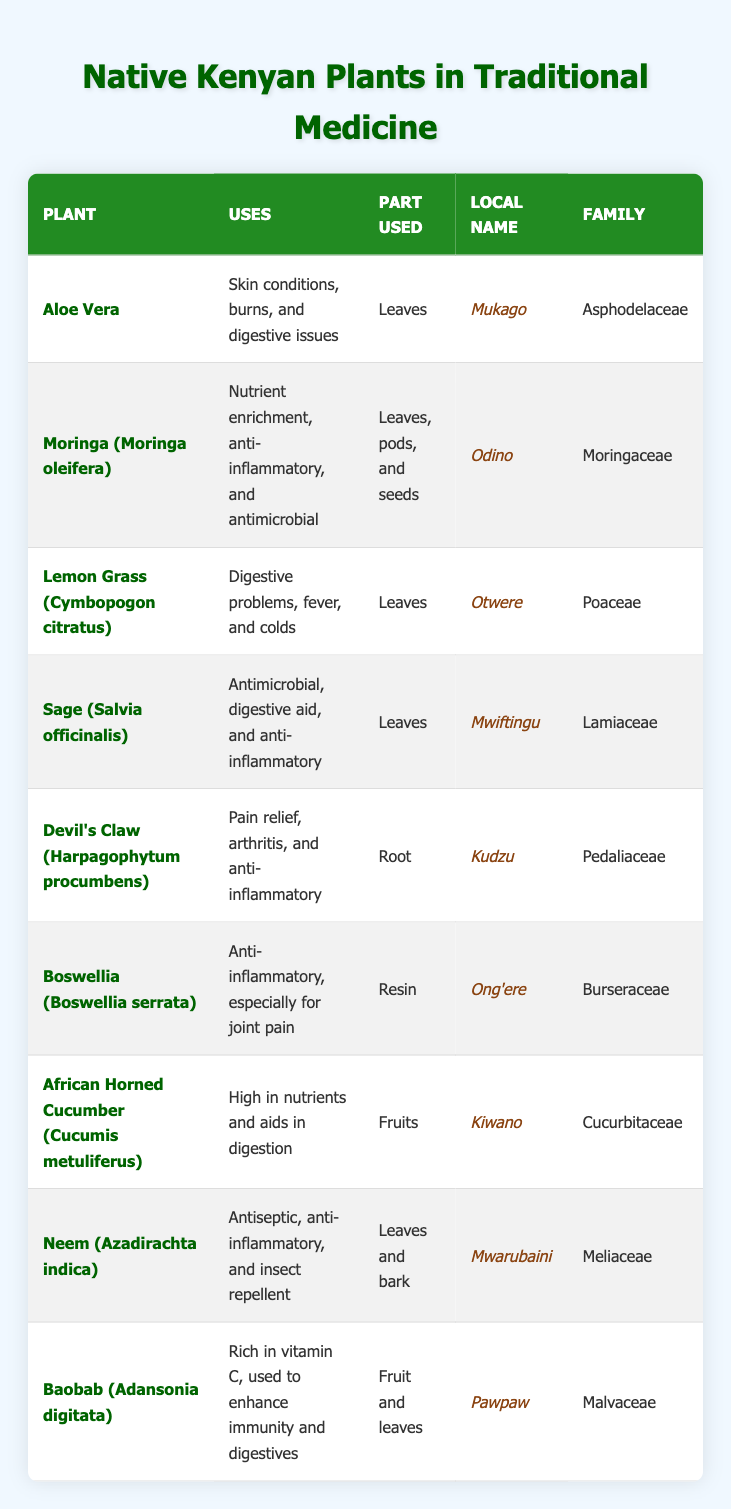What is the local name of Aloe Vera? In the table, under the "Local Name" column for the plant "Aloe Vera," it is listed as "Mukago."
Answer: Mukago Which part of the Moringa plant is used? The table specifies that for Moringa (Moringa oleifera), the parts used are "Leaves, pods, and seeds."
Answer: Leaves, pods, and seeds Is Neem used for antiseptic purposes? The table lists Neem (Azadirachta indica) under "Uses," mentioning antiseptic properties. Therefore, the answer is yes.
Answer: Yes How many plants listed are primarily used for digestive issues? The table mentions "Aloe Vera," "Lemon Grass," and "Baobab" as used for digestive issues. Counting these gives us three plants.
Answer: 3 Which plant has the highest diversity in parts used? Moringa (Moringa oleifera) is the only plant that lists "Leaves, pods, and seeds," showing varied usage. Therefore, it has the highest diversity with three parts.
Answer: Moringa What are the uses of the Baobab plant? The "Uses" column for Baobab (Adansonia digitata) indicates it is "Rich in vitamin C, used to enhance immunity and digestives."
Answer: Rich in vitamin C Which plants are in the Lamiaceae family? By reviewing the "Family" column, we can see that Sage (Salvia officinalis) is the only plant in the Lamiaceae family.
Answer: Sage List the parts used for Devil’s Claw. The table shows that the part used for Devil's Claw (Harpagophytum procumbens) is the "Root."
Answer: Root Are there any plants that are used as insect repellents? Neem (Azadirachta indica) is listed in the "Uses" column as having insect repellent properties, so the answer is yes.
Answer: Yes Among the listed plants, which part of the Boswellia tree is used? The "Part Used" column indicates that Boswellia (Boswellia serrata) uses "Resin."
Answer: Resin How many plants use leaves as part of their medicinal application? By counting the plants in the table, Aloe Vera, Moringa, Lemon Grass, Sage, Neem, and Baobab all use leaves, totaling six plants.
Answer: 6 